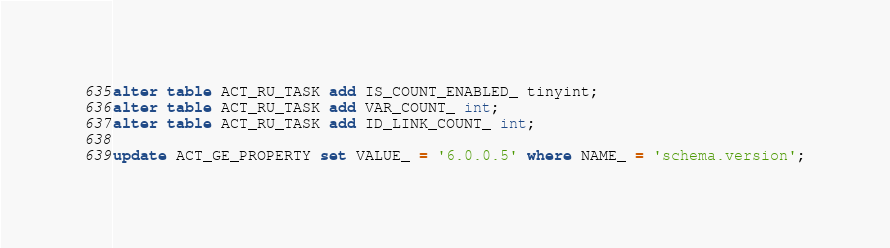<code> <loc_0><loc_0><loc_500><loc_500><_SQL_>alter table ACT_RU_TASK add IS_COUNT_ENABLED_ tinyint;
alter table ACT_RU_TASK add VAR_COUNT_ int;
alter table ACT_RU_TASK add ID_LINK_COUNT_ int;

update ACT_GE_PROPERTY set VALUE_ = '6.0.0.5' where NAME_ = 'schema.version';

</code> 